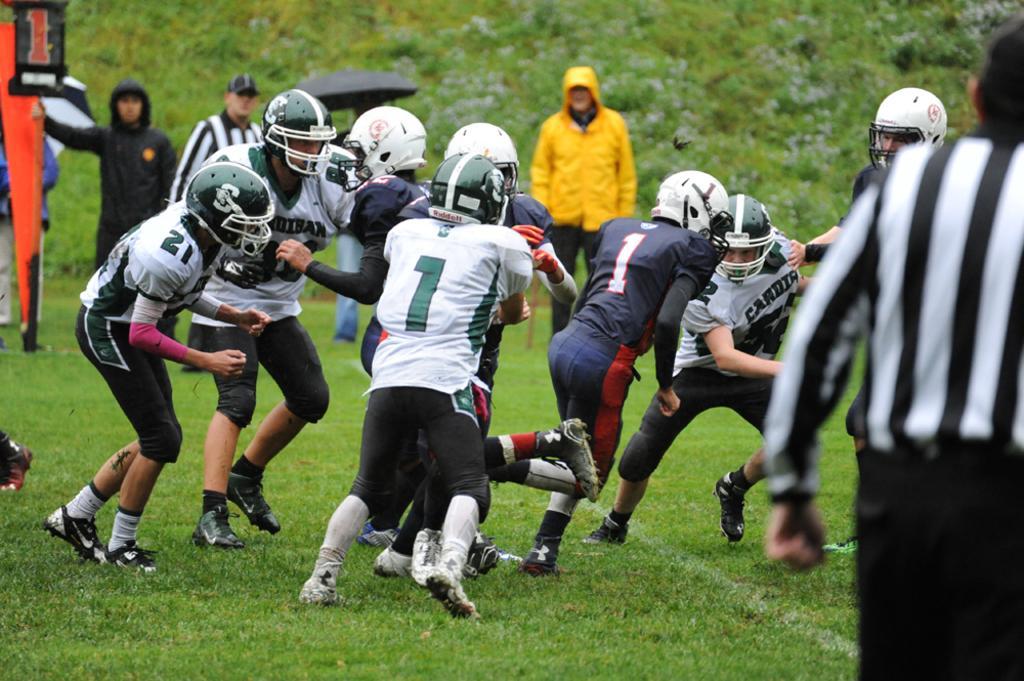Could you give a brief overview of what you see in this image? In this image I can see group of people playing game. The person in front wearing white shirt, black color pant, background I can see few other persons standing and trees in green color. 